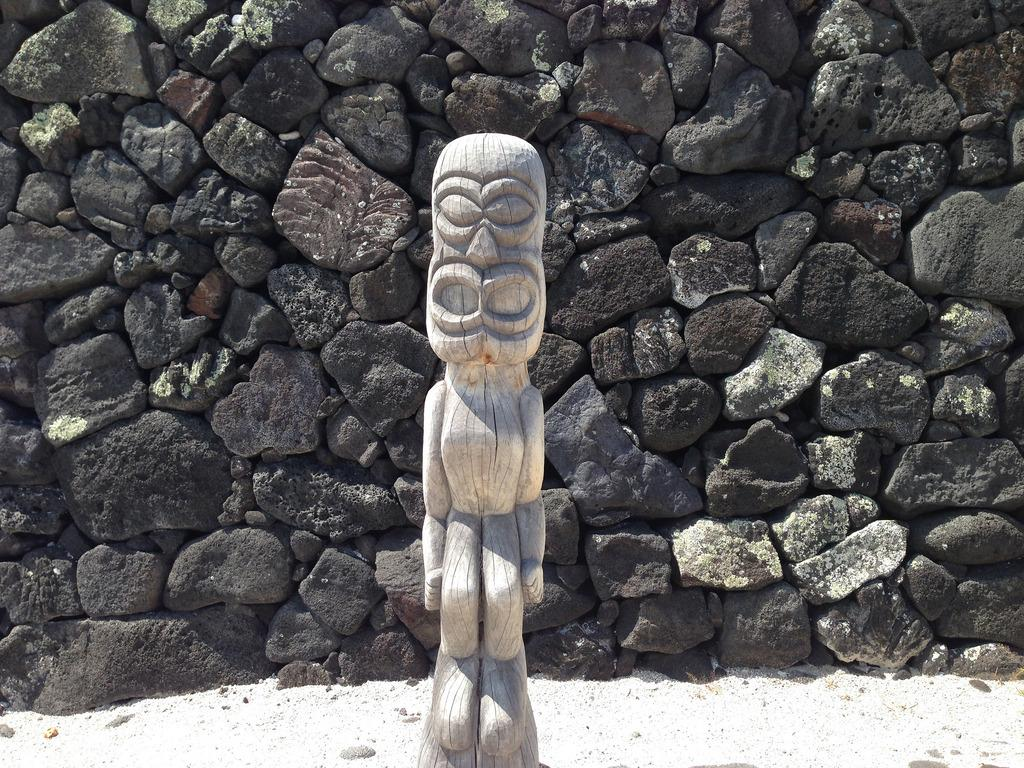What is the main subject of the image? There is a stone carved statue in the image. Where is the statue located in relation to the image? The statue is in front of the image. What can be seen at the bottom of the image? There are stones and pavement visible at the bottom of the image. What type of stones can be seen in the background of the image? There are black-colored stones in the background of the image. Can you tell me how the sea is shaking the statue in the image? There is no sea present in the image, and therefore no shaking of the statue can be observed. What is the statue doing to the person's throat in the image? There are no people or throats present in the image; it only features a stone carved statue. 